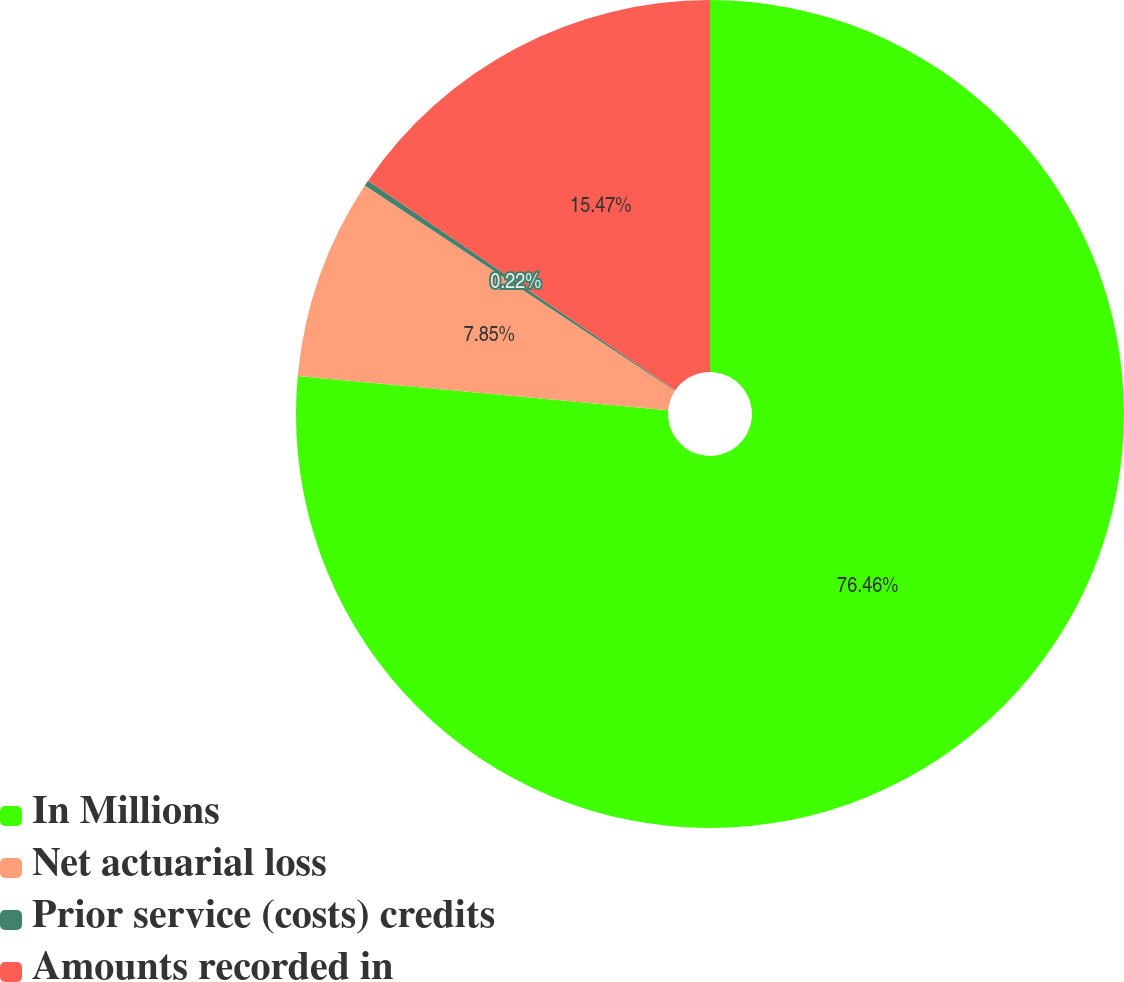<chart> <loc_0><loc_0><loc_500><loc_500><pie_chart><fcel>In Millions<fcel>Net actuarial loss<fcel>Prior service (costs) credits<fcel>Amounts recorded in<nl><fcel>76.46%<fcel>7.85%<fcel>0.22%<fcel>15.47%<nl></chart> 